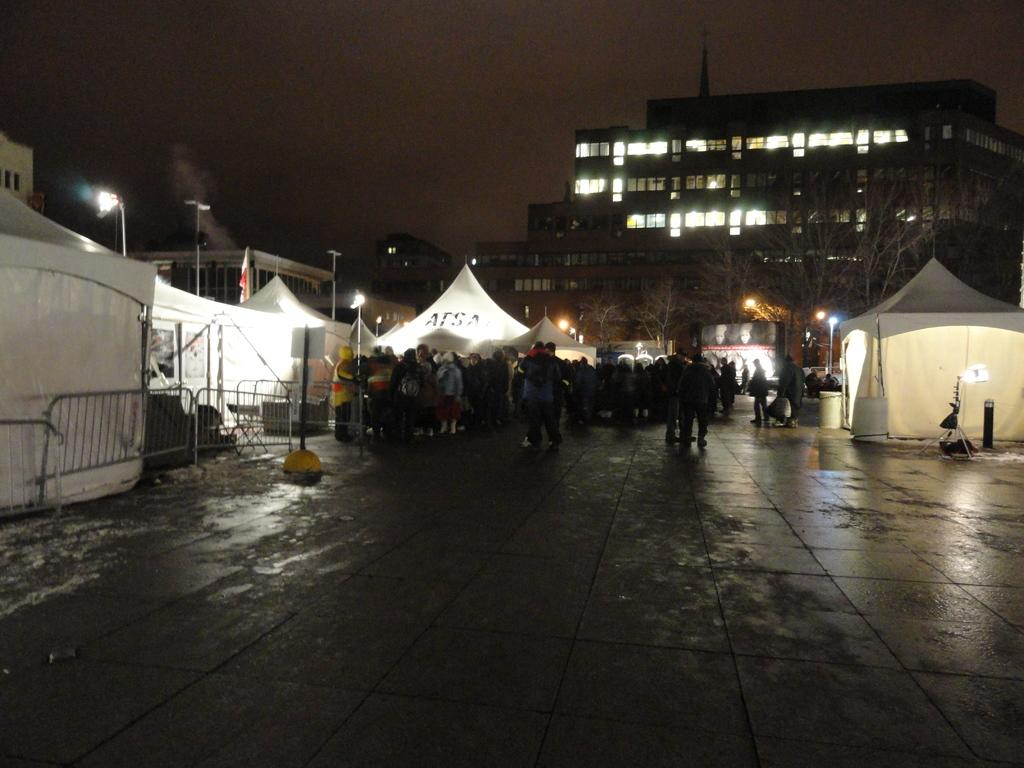How many people are in the image? There is a group of people in the image, but the exact number cannot be determined from the provided facts. What structures are visible in the image? There are tents and buildings in the image. What is the condition of the sky in the image? The sky appears to be dark in the image. What type of suit can be seen hanging on the tent in the image? There is no suit visible in the image; it only features a group of people, tents, and buildings. How many letters are present on the buildings in the image? The provided facts do not mention any letters on the buildings, so it is impossible to determine their quantity. 